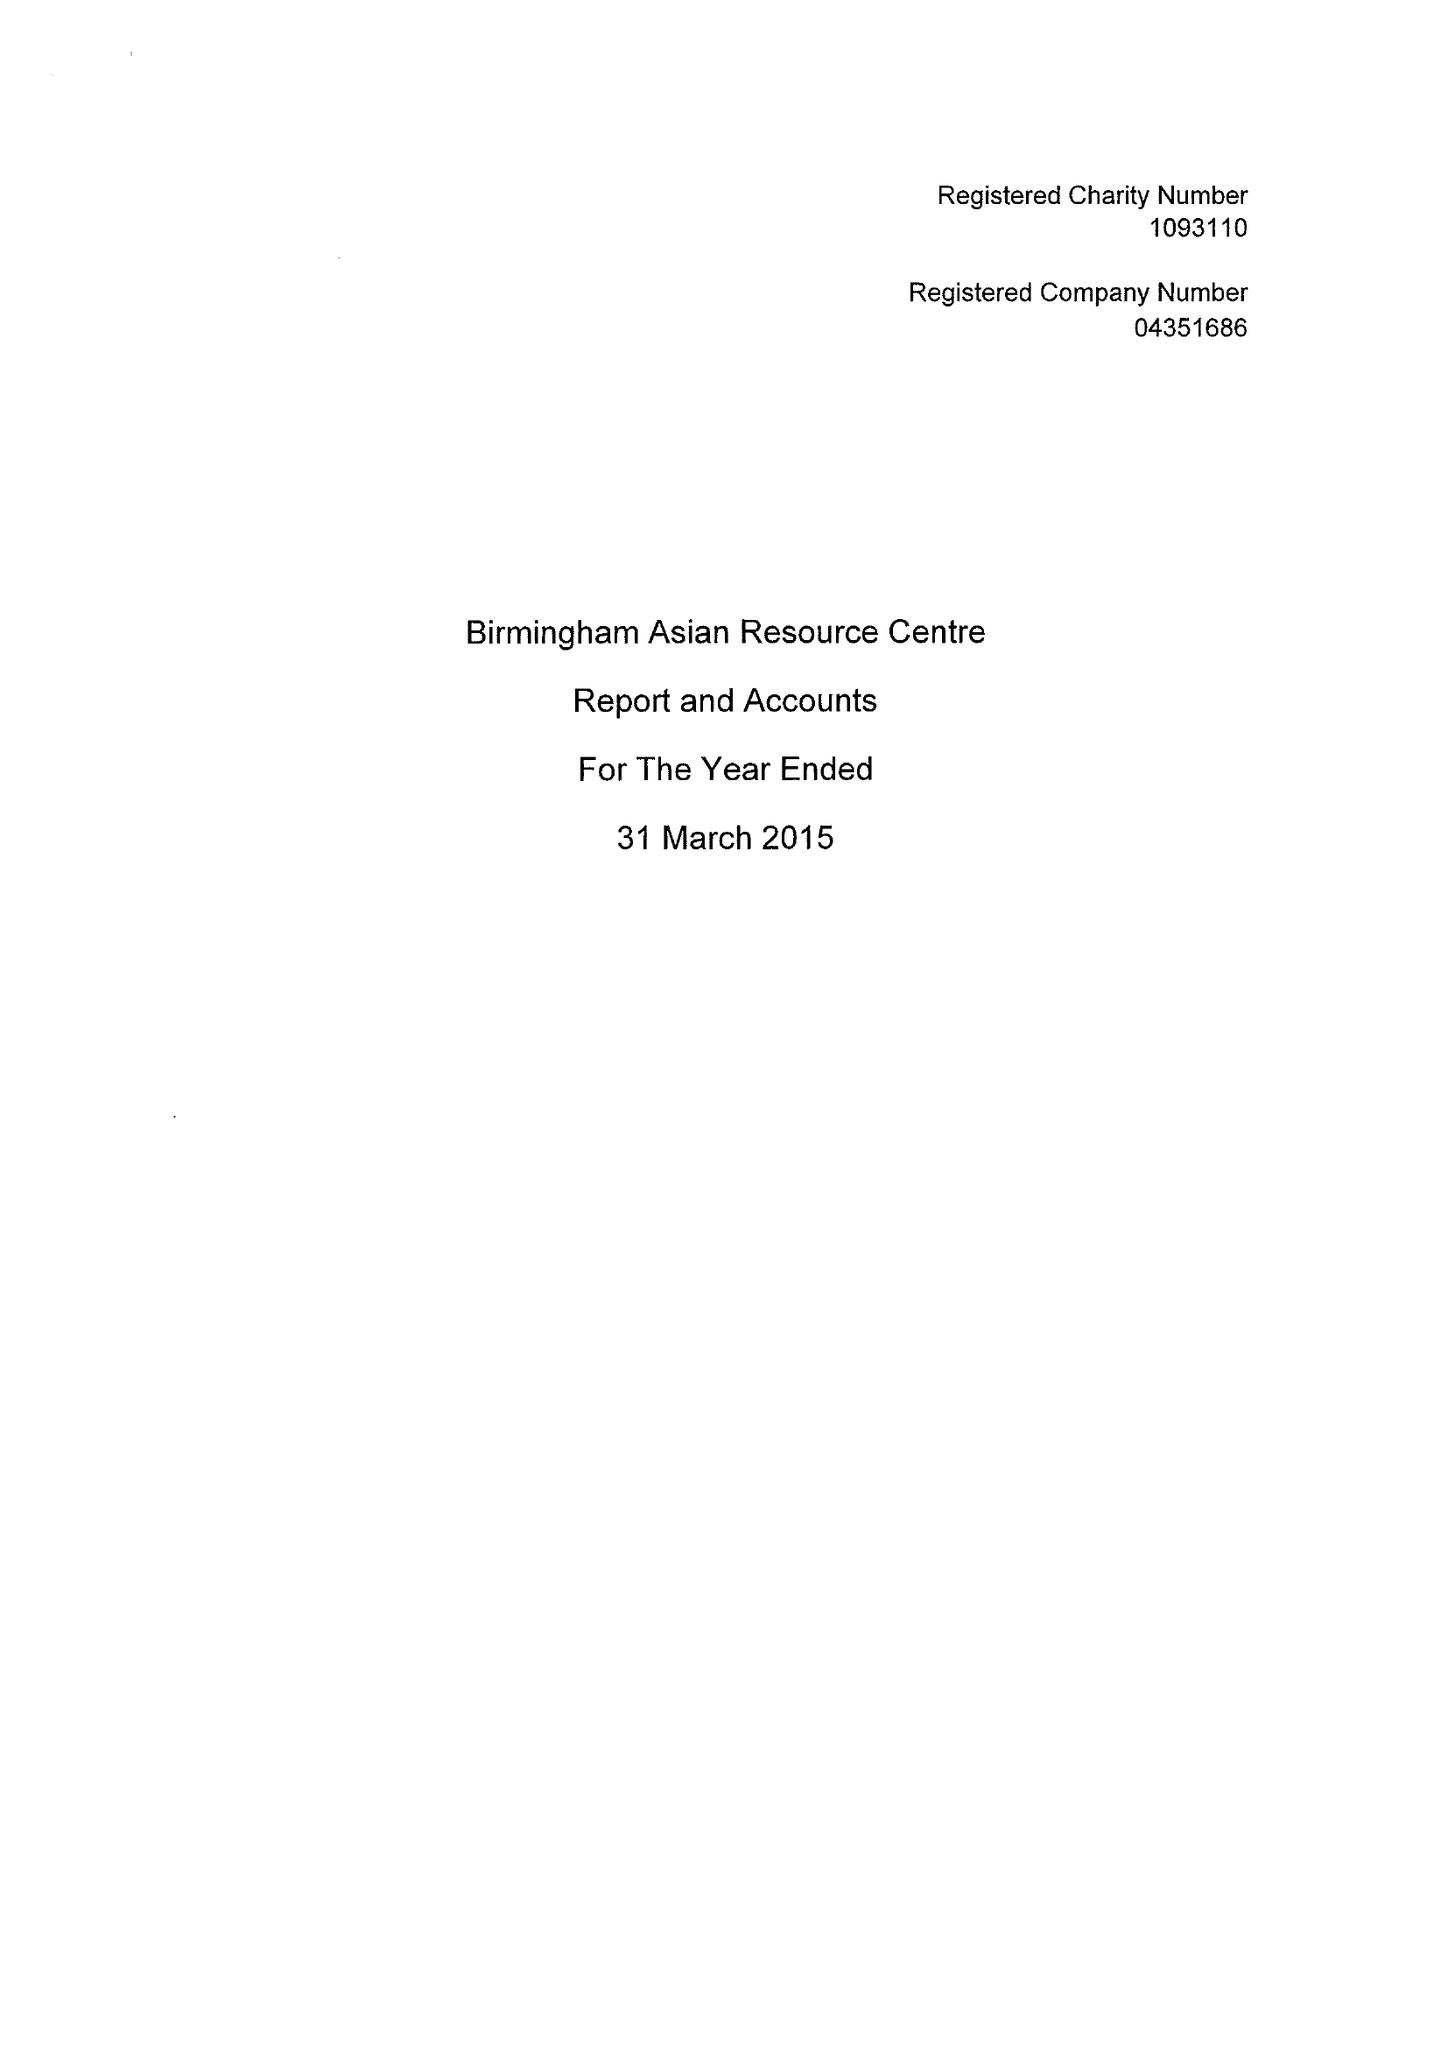What is the value for the address__postcode?
Answer the question using a single word or phrase. B20 2QS 